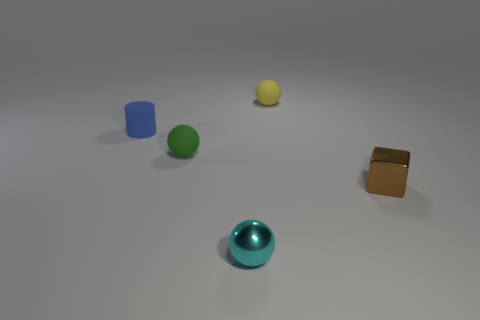What material is the tiny object that is left of the small brown thing and in front of the small green object?
Your answer should be very brief. Metal. What is the color of the tiny thing that is both to the right of the tiny cyan shiny sphere and left of the brown shiny cube?
Give a very brief answer. Yellow. Are there any other things that have the same color as the shiny cube?
Ensure brevity in your answer.  No. The shiny object to the left of the rubber ball behind the rubber object that is in front of the small matte cylinder is what shape?
Your answer should be very brief. Sphere. What is the color of the tiny metal object that is the same shape as the yellow matte thing?
Your answer should be very brief. Cyan. What is the color of the small matte sphere on the right side of the small sphere in front of the tiny brown block?
Keep it short and to the point. Yellow. What size is the yellow rubber thing that is the same shape as the cyan thing?
Your answer should be compact. Small. What number of brown cubes have the same material as the green thing?
Your answer should be very brief. 0. What number of objects are on the left side of the metal thing that is left of the brown metallic block?
Your response must be concise. 2. Are there any matte objects in front of the cyan sphere?
Your response must be concise. No. 